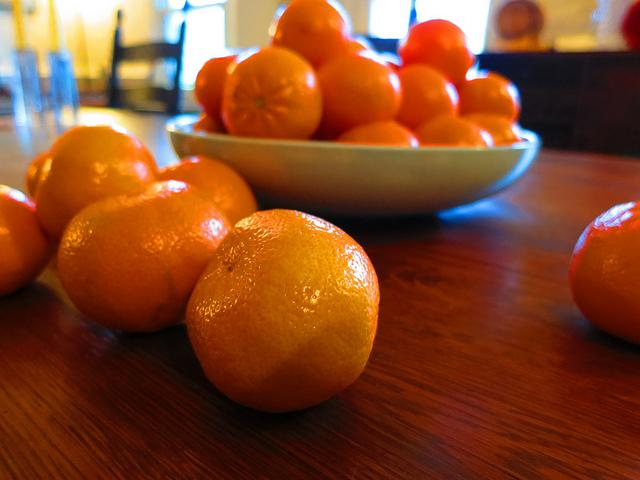What utensil is usually needed with this food? Please explain your reasoning. knife. You need that to cut the oranges. 